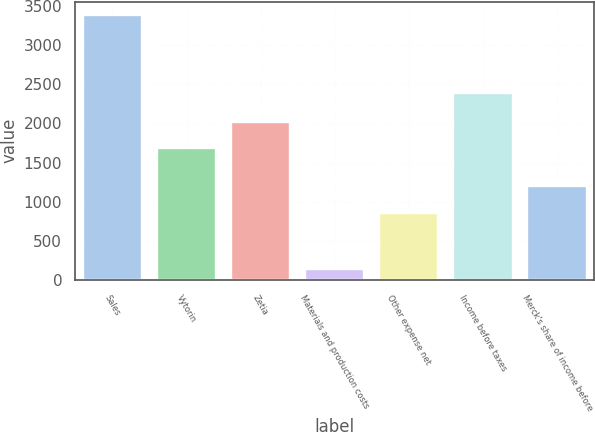Convert chart. <chart><loc_0><loc_0><loc_500><loc_500><bar_chart><fcel>Sales<fcel>Vytorin<fcel>Zetia<fcel>Materials and production costs<fcel>Other expense net<fcel>Income before taxes<fcel>Merck's share of income before<nl><fcel>3387<fcel>1689<fcel>2013.3<fcel>144<fcel>849<fcel>2394<fcel>1198<nl></chart> 